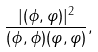<formula> <loc_0><loc_0><loc_500><loc_500>\frac { | ( \phi , \varphi ) | ^ { 2 } } { ( \phi , \phi ) ( \varphi , \varphi ) } ,</formula> 